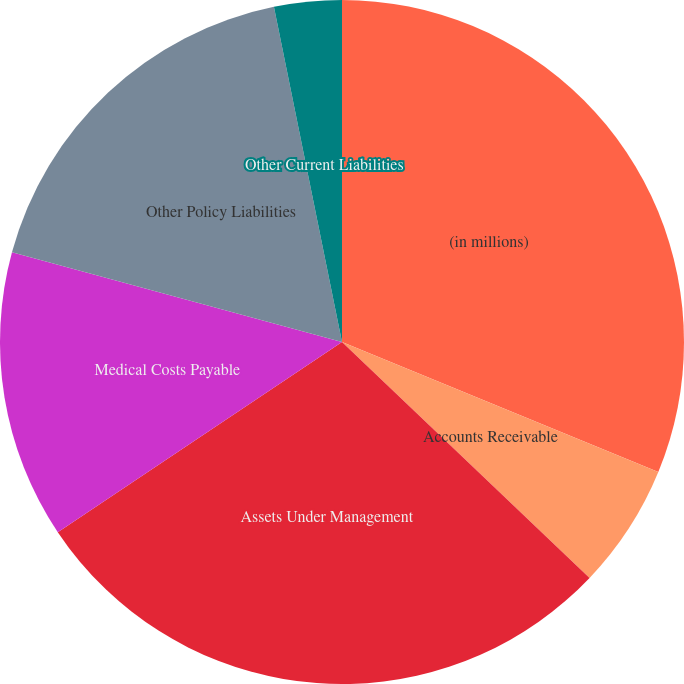Convert chart. <chart><loc_0><loc_0><loc_500><loc_500><pie_chart><fcel>(in millions)<fcel>Accounts Receivable<fcel>Assets Under Management<fcel>Medical Costs Payable<fcel>Other Policy Liabilities<fcel>Other Current Liabilities<nl><fcel>31.21%<fcel>5.91%<fcel>28.5%<fcel>13.61%<fcel>17.59%<fcel>3.19%<nl></chart> 